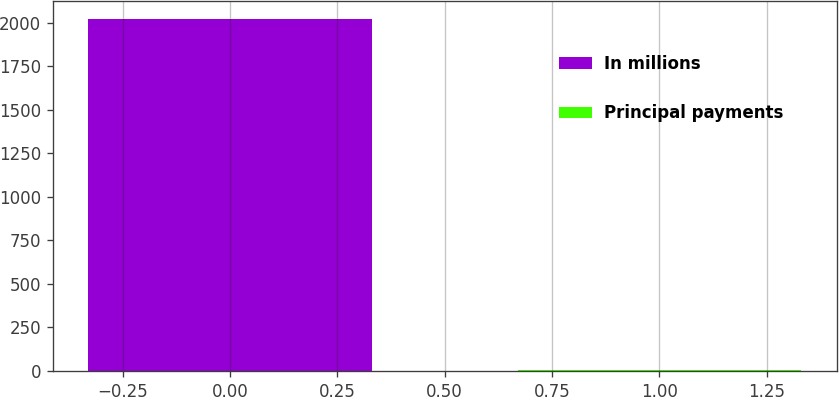Convert chart to OTSL. <chart><loc_0><loc_0><loc_500><loc_500><bar_chart><fcel>In millions<fcel>Principal payments<nl><fcel>2021<fcel>4<nl></chart> 